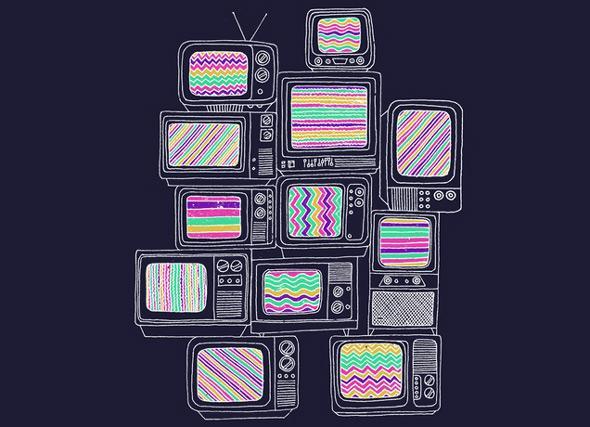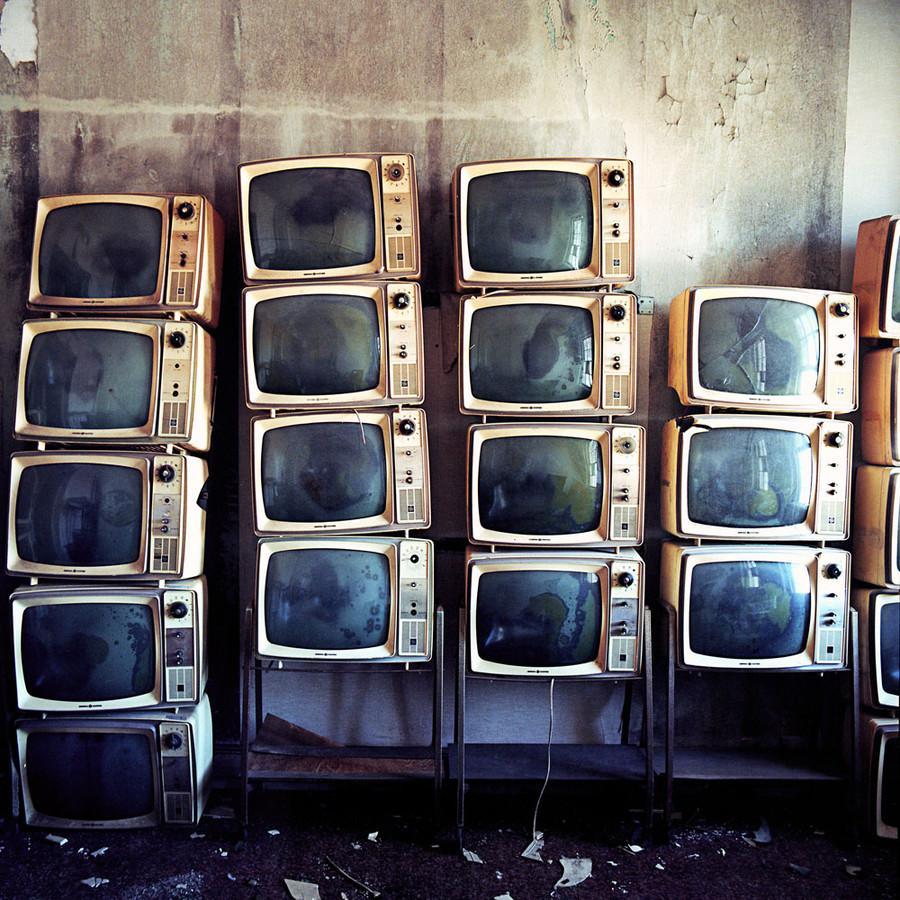The first image is the image on the left, the second image is the image on the right. Evaluate the accuracy of this statement regarding the images: "A stack of old-fashioned TVs includes at least one with a rainbow test pattern and two knobs in a vertical row alongside the screen.". Is it true? Answer yes or no. Yes. The first image is the image on the left, the second image is the image on the right. For the images shown, is this caption "The right image contains exactly five old fashioned television sets." true? Answer yes or no. No. 